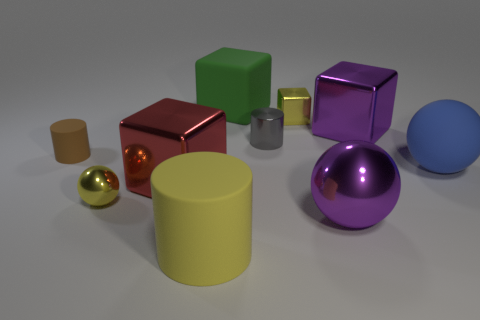Are there any patterns or consistencies in the arrangement of objects? The objects are arranged in a somewhat scattered, but balanced way, with no apparent pattern to their placement. However, there is consistency in the variation of shapes and sizes, providing visual interest and suggesting an intentional design for displaying diversity in form and color. 